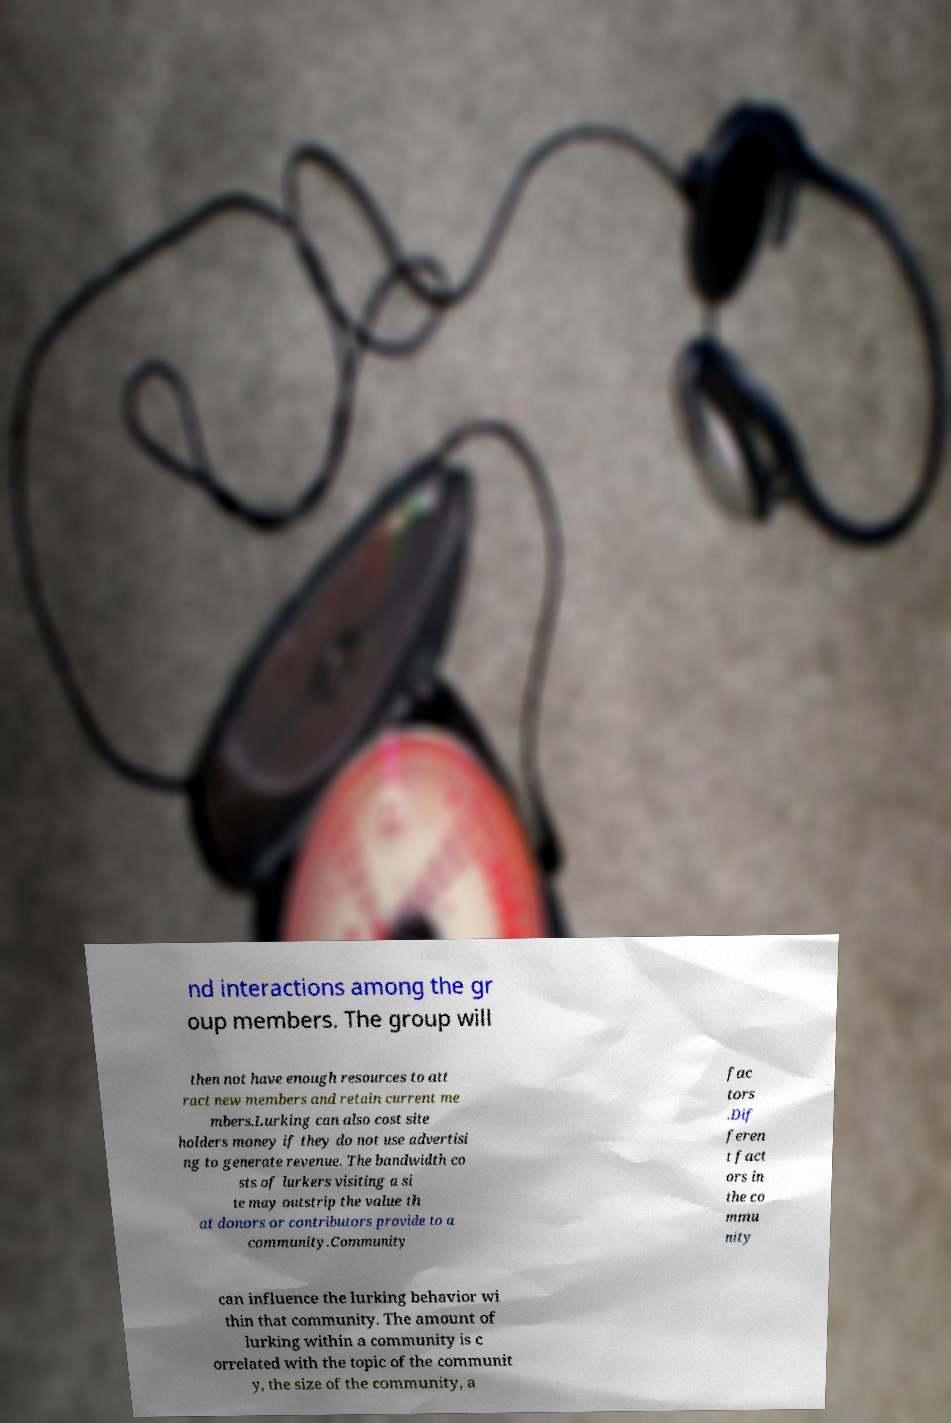Can you accurately transcribe the text from the provided image for me? nd interactions among the gr oup members. The group will then not have enough resources to att ract new members and retain current me mbers.Lurking can also cost site holders money if they do not use advertisi ng to generate revenue. The bandwidth co sts of lurkers visiting a si te may outstrip the value th at donors or contributors provide to a community.Community fac tors .Dif feren t fact ors in the co mmu nity can influence the lurking behavior wi thin that community. The amount of lurking within a community is c orrelated with the topic of the communit y, the size of the community, a 